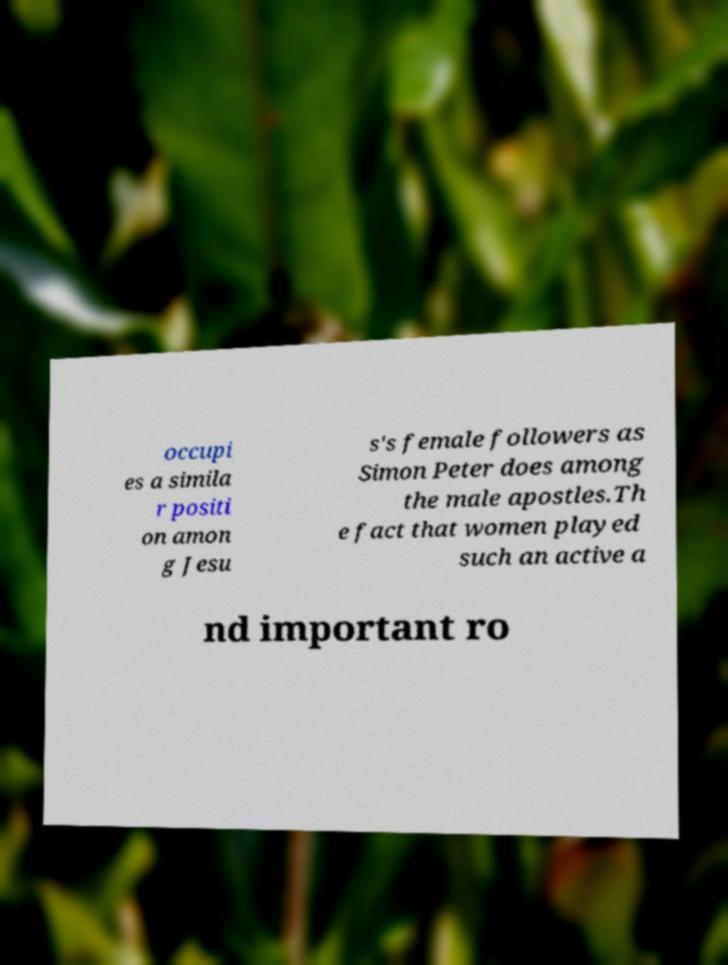Can you read and provide the text displayed in the image?This photo seems to have some interesting text. Can you extract and type it out for me? occupi es a simila r positi on amon g Jesu s's female followers as Simon Peter does among the male apostles.Th e fact that women played such an active a nd important ro 